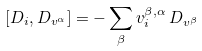Convert formula to latex. <formula><loc_0><loc_0><loc_500><loc_500>[ D _ { i } , D _ { v ^ { \alpha } } ] = - \sum _ { \beta } v _ { i } ^ { \beta , \alpha } \, D _ { v ^ { \beta } }</formula> 